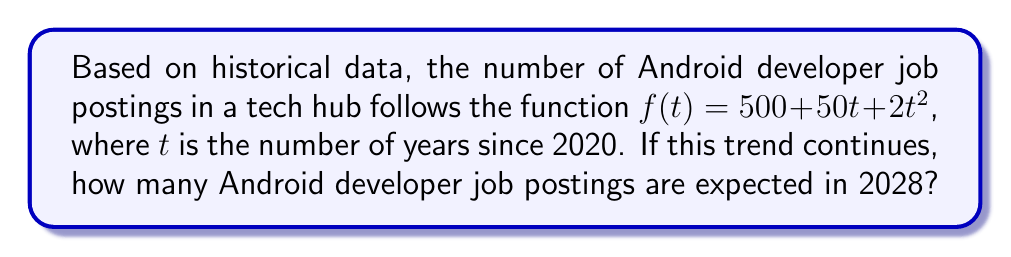Help me with this question. To solve this problem, we need to follow these steps:

1. Identify the given information:
   - The function for job postings is $f(t) = 500 + 50t + 2t^2$
   - $t$ represents the number of years since 2020
   - We need to find the number of job postings in 2028

2. Calculate the value of $t$ for the year 2028:
   - 2028 is 8 years after 2020
   - Therefore, $t = 8$

3. Substitute $t = 8$ into the function:
   $f(8) = 500 + 50(8) + 2(8^2)$

4. Evaluate the expression:
   $f(8) = 500 + 400 + 2(64)$
   $f(8) = 500 + 400 + 128$
   $f(8) = 1028$

Therefore, if the trend continues, there will be 1028 Android developer job postings expected in 2028.
Answer: 1028 job postings 